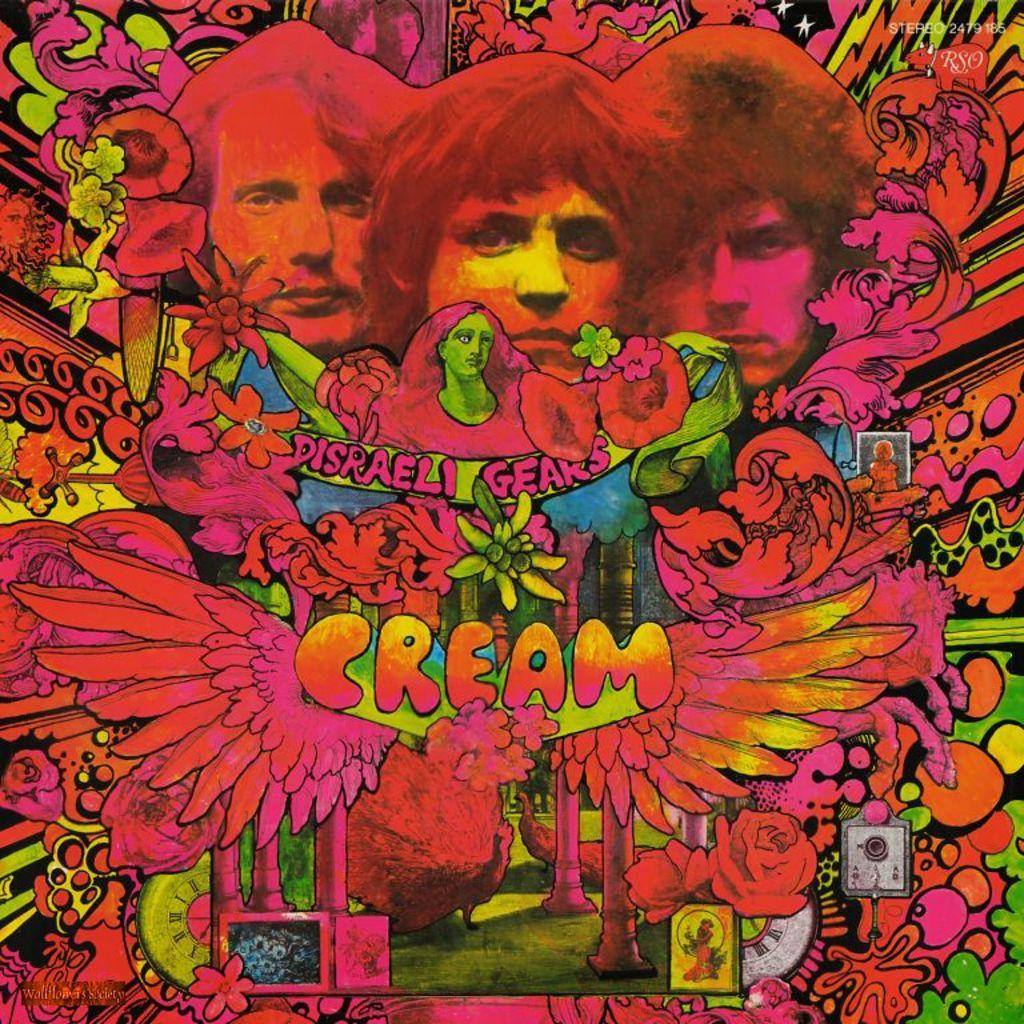<image>
Offer a succinct explanation of the picture presented. A brightly colored psychedelic poster says, "CREAM" on it. 